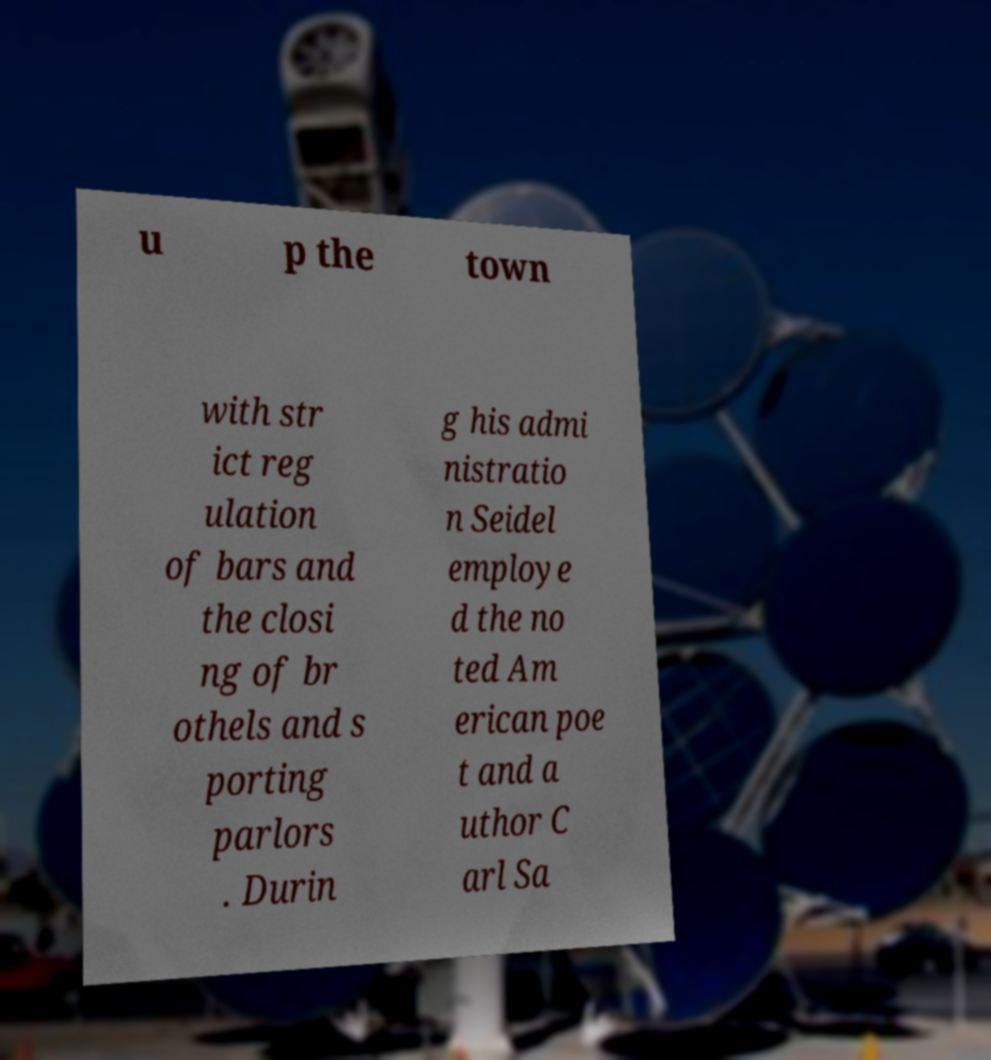Please identify and transcribe the text found in this image. u p the town with str ict reg ulation of bars and the closi ng of br othels and s porting parlors . Durin g his admi nistratio n Seidel employe d the no ted Am erican poe t and a uthor C arl Sa 